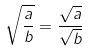Convert formula to latex. <formula><loc_0><loc_0><loc_500><loc_500>\sqrt { \frac { a } { b } } = \frac { \sqrt { a } } { \sqrt { b } }</formula> 